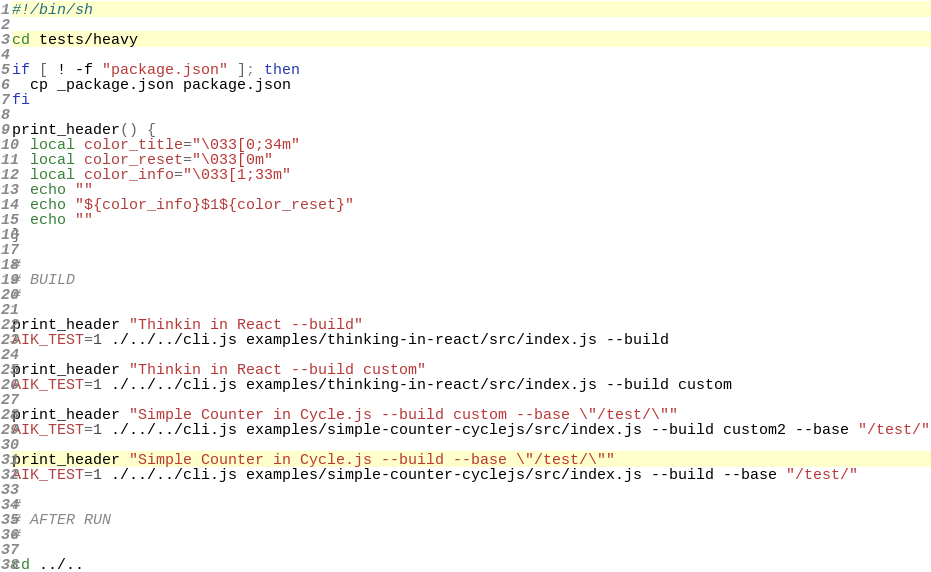<code> <loc_0><loc_0><loc_500><loc_500><_Bash_>#!/bin/sh

cd tests/heavy

if [ ! -f "package.json" ]; then
  cp _package.json package.json
fi

print_header() {
  local color_title="\033[0;34m"
  local color_reset="\033[0m"
  local color_info="\033[1;33m"
  echo ""
  echo "${color_info}$1${color_reset}"
  echo ""
}

#
# BUILD
#

print_header "Thinkin in React --build"
AIK_TEST=1 ./../../cli.js examples/thinking-in-react/src/index.js --build

print_header "Thinkin in React --build custom"
AIK_TEST=1 ./../../cli.js examples/thinking-in-react/src/index.js --build custom

print_header "Simple Counter in Cycle.js --build custom --base \"/test/\""
AIK_TEST=1 ./../../cli.js examples/simple-counter-cyclejs/src/index.js --build custom2 --base "/test/"

print_header "Simple Counter in Cycle.js --build --base \"/test/\""
AIK_TEST=1 ./../../cli.js examples/simple-counter-cyclejs/src/index.js --build --base "/test/"

#
# AFTER RUN
#

cd ../..
</code> 